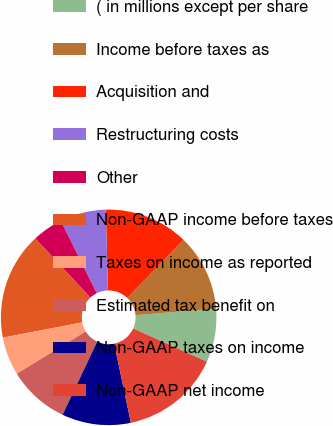Convert chart to OTSL. <chart><loc_0><loc_0><loc_500><loc_500><pie_chart><fcel>( in millions except per share<fcel>Income before taxes as<fcel>Acquisition and<fcel>Restructuring costs<fcel>Other<fcel>Non-GAAP income before taxes<fcel>Taxes on income as reported<fcel>Estimated tax benefit on<fcel>Non-GAAP taxes on income<fcel>Non-GAAP net income<nl><fcel>8.05%<fcel>11.49%<fcel>12.64%<fcel>6.9%<fcel>4.6%<fcel>16.09%<fcel>5.75%<fcel>9.2%<fcel>10.34%<fcel>14.94%<nl></chart> 